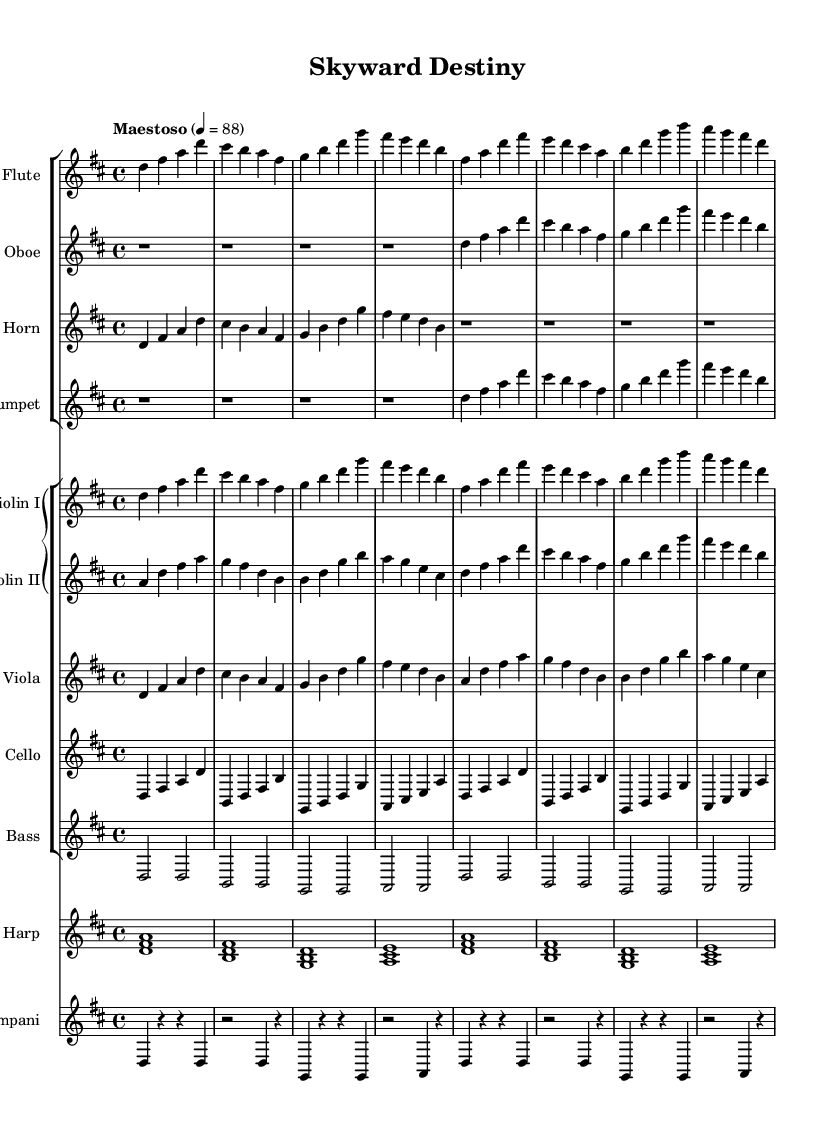What is the key signature of this music? The key signature is two sharps, which means it is in D major. D major has F# and C#.
Answer: D major What is the time signature of this music? The time signature is 4/4, indicated at the beginning of the sheet music, meaning there are four beats per measure.
Answer: 4/4 What is the tempo marking for this piece? The tempo marking is "Maestoso", which signals a slow, dignified tempo, usually around 88 BPM.
Answer: Maestoso How many measures does the flute part have? The flute part has a total of 8 measures, counting the notation on the staff.
Answer: 8 measures What is the instrumental ensemble type used in this piece? The ensemble features woodwinds, strings, and percussion, creating a rich orchestral sound typical of epic themes.
Answer: Orchestral Which instrument has a resting measure at the beginning? The oboe part begins with four measures of rest, indicating that the oboe does not play in the first four measures.
Answer: Oboe Is there a harmony section indicated in the music? Yes, multi-instrumental parts like the strings and horns create harmony throughout the piece, fulfilling a rich orchestral texture.
Answer: Yes 